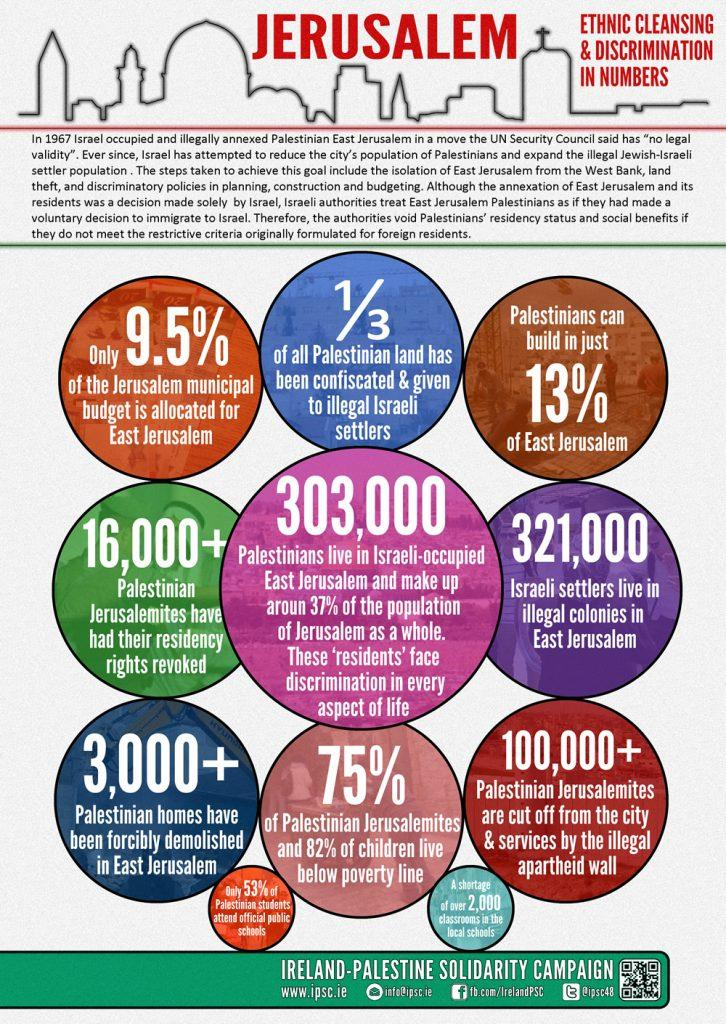Point out several critical features in this image. According to recent estimates, the population of Palestinian Jerusalemites who have had their residency rights revoked is approximately 16,000 individuals or more. According to recent estimates, approximately 37% of the population of Jerusalem is comprised of Palestinians. According to estimates, over 3,000 Palestinian homes in East Jerusalem have been forcibly demolished. According to recent data, an overwhelming 75% of Palestinian Jerusalemites are living in poverty, a statistic that highlights the significant socio-economic challenges facing this community. According to recent estimates, approximately 321,000 Israeli settlers currently reside in illegal colonies in East Jerusalem. 